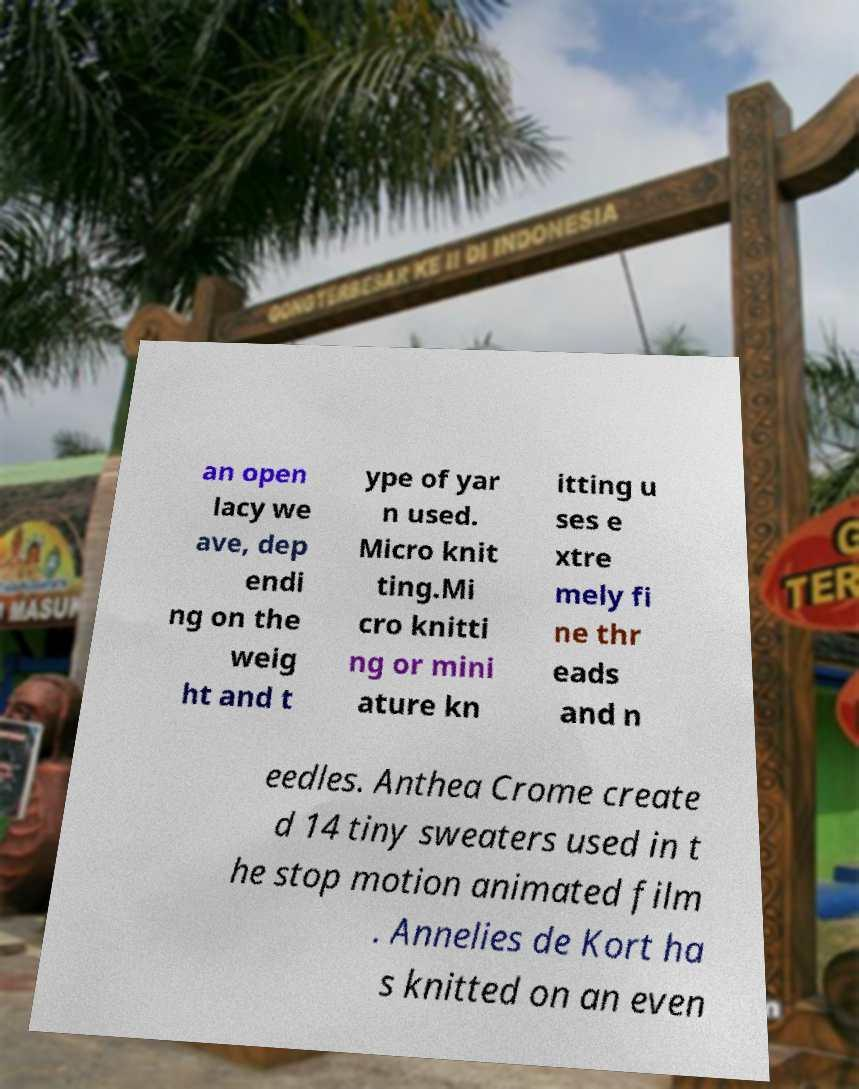I need the written content from this picture converted into text. Can you do that? an open lacy we ave, dep endi ng on the weig ht and t ype of yar n used. Micro knit ting.Mi cro knitti ng or mini ature kn itting u ses e xtre mely fi ne thr eads and n eedles. Anthea Crome create d 14 tiny sweaters used in t he stop motion animated film . Annelies de Kort ha s knitted on an even 